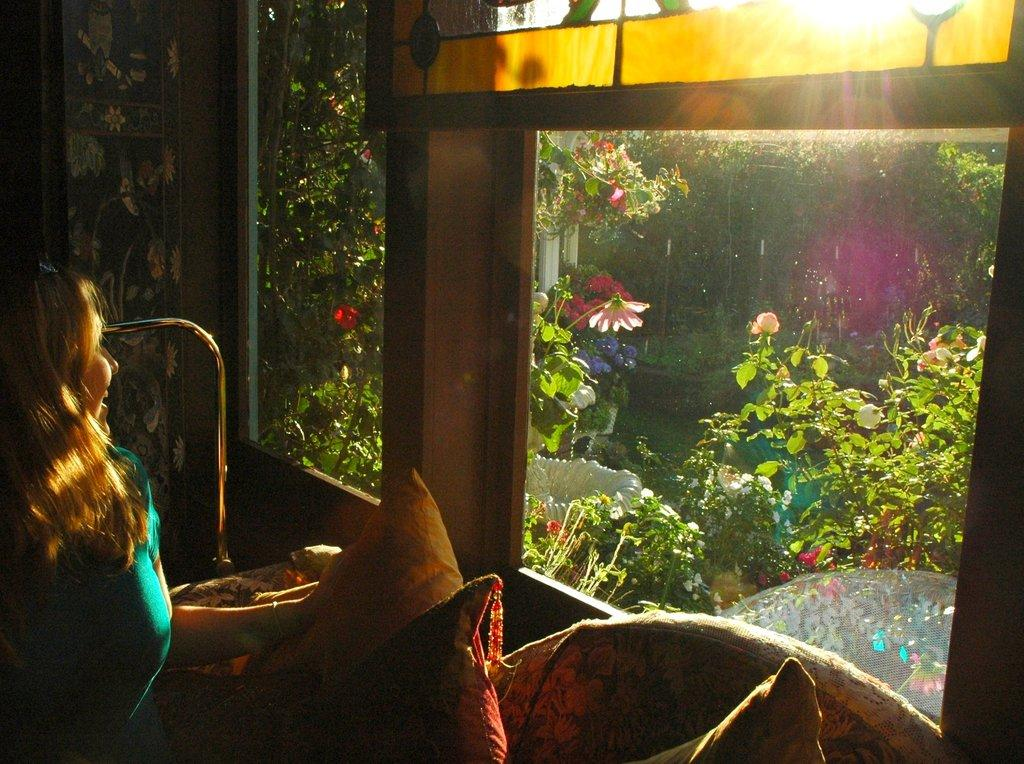Who is present in the image? There is a woman in the image. What is the woman holding in the image? The woman is holding an object. Where is the object located in the image? The object is in the left corner of the image. What can be seen in the background of the image? There are plants and trees in the background of the image. What type of furniture is the woman sitting on in the image? There is no furniture visible in the image, as the woman is standing and holding an object. What color is the coat the woman is wearing in the image? The woman is not wearing a coat in the image; she is holding an object. 